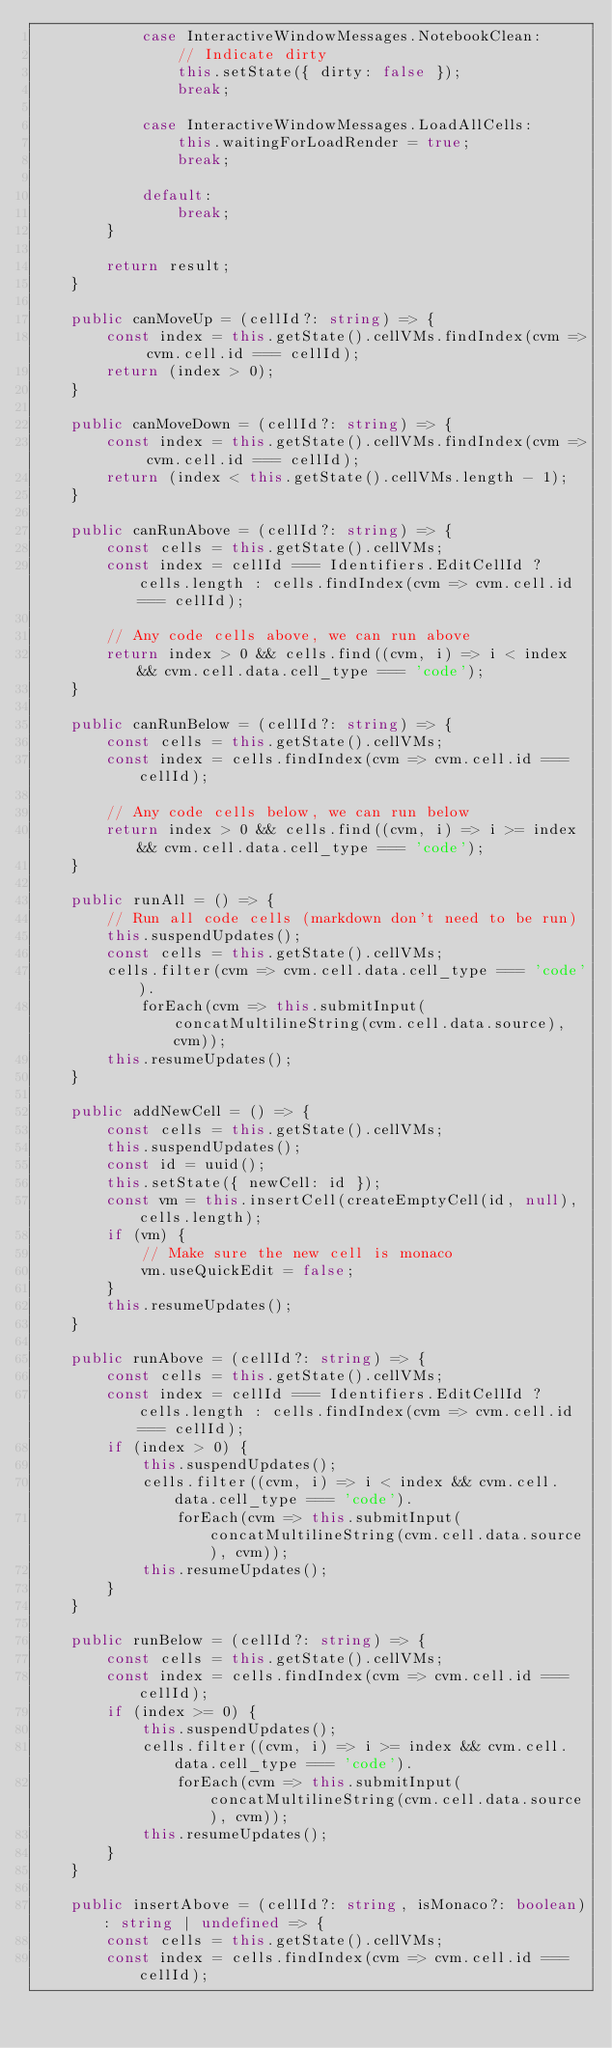<code> <loc_0><loc_0><loc_500><loc_500><_TypeScript_>            case InteractiveWindowMessages.NotebookClean:
                // Indicate dirty
                this.setState({ dirty: false });
                break;

            case InteractiveWindowMessages.LoadAllCells:
                this.waitingForLoadRender = true;
                break;

            default:
                break;
        }

        return result;
    }

    public canMoveUp = (cellId?: string) => {
        const index = this.getState().cellVMs.findIndex(cvm => cvm.cell.id === cellId);
        return (index > 0);
    }

    public canMoveDown = (cellId?: string) => {
        const index = this.getState().cellVMs.findIndex(cvm => cvm.cell.id === cellId);
        return (index < this.getState().cellVMs.length - 1);
    }

    public canRunAbove = (cellId?: string) => {
        const cells = this.getState().cellVMs;
        const index = cellId === Identifiers.EditCellId ? cells.length : cells.findIndex(cvm => cvm.cell.id === cellId);

        // Any code cells above, we can run above
        return index > 0 && cells.find((cvm, i) => i < index && cvm.cell.data.cell_type === 'code');
    }

    public canRunBelow = (cellId?: string) => {
        const cells = this.getState().cellVMs;
        const index = cells.findIndex(cvm => cvm.cell.id === cellId);

        // Any code cells below, we can run below
        return index > 0 && cells.find((cvm, i) => i >= index && cvm.cell.data.cell_type === 'code');
    }

    public runAll = () => {
        // Run all code cells (markdown don't need to be run)
        this.suspendUpdates();
        const cells = this.getState().cellVMs;
        cells.filter(cvm => cvm.cell.data.cell_type === 'code').
            forEach(cvm => this.submitInput(concatMultilineString(cvm.cell.data.source), cvm));
        this.resumeUpdates();
    }

    public addNewCell = () => {
        const cells = this.getState().cellVMs;
        this.suspendUpdates();
        const id = uuid();
        this.setState({ newCell: id });
        const vm = this.insertCell(createEmptyCell(id, null), cells.length);
        if (vm) {
            // Make sure the new cell is monaco
            vm.useQuickEdit = false;
        }
        this.resumeUpdates();
    }

    public runAbove = (cellId?: string) => {
        const cells = this.getState().cellVMs;
        const index = cellId === Identifiers.EditCellId ? cells.length : cells.findIndex(cvm => cvm.cell.id === cellId);
        if (index > 0) {
            this.suspendUpdates();
            cells.filter((cvm, i) => i < index && cvm.cell.data.cell_type === 'code').
                forEach(cvm => this.submitInput(concatMultilineString(cvm.cell.data.source), cvm));
            this.resumeUpdates();
        }
    }

    public runBelow = (cellId?: string) => {
        const cells = this.getState().cellVMs;
        const index = cells.findIndex(cvm => cvm.cell.id === cellId);
        if (index >= 0) {
            this.suspendUpdates();
            cells.filter((cvm, i) => i >= index && cvm.cell.data.cell_type === 'code').
                forEach(cvm => this.submitInput(concatMultilineString(cvm.cell.data.source), cvm));
            this.resumeUpdates();
        }
    }

    public insertAbove = (cellId?: string, isMonaco?: boolean): string | undefined => {
        const cells = this.getState().cellVMs;
        const index = cells.findIndex(cvm => cvm.cell.id === cellId);</code> 